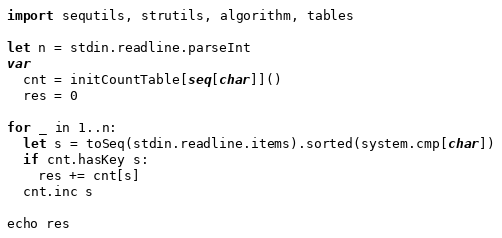Convert code to text. <code><loc_0><loc_0><loc_500><loc_500><_Nim_>import sequtils, strutils, algorithm, tables

let n = stdin.readline.parseInt
var
  cnt = initCountTable[seq[char]]()
  res = 0

for _ in 1..n:
  let s = toSeq(stdin.readline.items).sorted(system.cmp[char])
  if cnt.hasKey s:
    res += cnt[s]
  cnt.inc s

echo res
</code> 